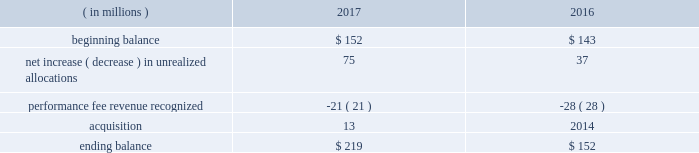When the likelihood of clawback is considered mathematically improbable .
The company records a deferred carried interest liability to the extent it receives cash or capital allocations related to carried interest prior to meeting the revenue recognition criteria .
At december 31 , 2017 and 2016 , the company had $ 219 million and $ 152 million , respectively , of deferred carried interest recorded in other liabilities/other liabilities of consolidated vies on the consolidated statements of financial condition .
A portion of the deferred carried interest liability will be paid to certain employees .
The ultimate timing of the recognition of performance fee revenue , if any , for these products is unknown .
The table presents changes in the deferred carried interest liability ( including the portion related to consolidated vies ) for 2017 and 2016: .
For 2017 , 2016 and 2015 , performance fee revenue ( which included recognized carried interest ) totaled $ 594 million , $ 295 million and $ 621 million , respectively .
Fees earned for technology and risk management revenue are recorded as services are performed and are generally determined using the value of positions on the aladdin platform or on a fixed-rate basis .
For 2017 , 2016 and 2016 , technology and risk management revenue totaled $ 677 million , $ 595 million and $ 528 million , respectively .
Adjustments to revenue arising from initial estimates recorded historically have been immaterial since the majority of blackrock 2019s investment advisory and administration revenue is calculated based on aum and since the company does not record performance fee revenue until performance thresholds have been exceeded and the likelihood of clawback is mathematically improbable .
Accounting developments recent accounting pronouncements not yet adopted .
Revenue from contracts with customers .
In may 2014 , the financial accounting standards board ( 201cfasb 201d ) issued accounting standards update ( 201casu 201d ) 2014-09 , revenue from contracts with customers ( 201casu 2014-09 201d ) .
Asu 2014-09 outlines a single comprehensive model for entities to use in accounting for revenue arising from contracts with customers and supersedes most current revenue recognition guidance , including industry-specific guidance .
The guidance also changes the accounting for certain contract costs and revises the criteria for determining if an entity is acting as a principal or agent in certain arrangements .
The key changes in the standard that impact the company 2019s revenue recognition relate to the presentation of certain revenue contracts and associated contract costs .
The most significant of these changes relates to the presentation of certain distribution costs , which are currently presented net against revenues ( contra-revenue ) and will be presented as an expense on a gross basis .
The company adopted asu 2014-09 effective january 1 , 2018 on a full retrospective basis , which will require 2016 and 2017 to be restated in future filings .
The cumulative effect adjustment to the 2016 opening retained earnings was not material .
The company currently expects the net gross up to revenue to be approximately $ 1 billion with a corresponding gross up to expense for both 2016 and 2017 .
Consequently , the company expects its gaap operating margin to decline upon adoption due to the gross up of revenue .
However , no material impact is expected on the company 2019s as adjusted operating margin .
For accounting pronouncements that the company adopted during the year ended december 31 , 2017 and for additional recent accounting pronouncements not yet adopted , see note 2 , significant accounting policies , in the consolidated financial statements contained in part ii , item 8 of this filing .
Item 7a .
Quantitative and qualitative disclosures about market risk aum market price risk .
Blackrock 2019s investment advisory and administration fees are primarily comprised of fees based on a percentage of the value of aum and , in some cases , performance fees expressed as a percentage of the returns realized on aum .
At december 31 , 2017 , the majority of the company 2019s investment advisory and administration fees were based on average or period end aum of the applicable investment funds or separate accounts .
Movements in equity market prices , interest rates/credit spreads , foreign exchange rates or all three could cause the value of aum to decline , which would result in lower investment advisory and administration fees .
Corporate investments portfolio risks .
As a leading investment management firm , blackrock devotes significant resources across all of its operations to identifying , measuring , monitoring , managing and analyzing market and operating risks , including the management and oversight of its own investment portfolio .
The board of directors of the company has adopted guidelines for the review of investments to be made by the company , requiring , among other things , that investments be reviewed by certain senior officers of the company , and that certain investments may be referred to the audit committee or the board of directors , depending on the circumstances , for approval .
In the normal course of its business , blackrock is exposed to equity market price risk , interest rate/credit spread risk and foreign exchange rate risk associated with its corporate investments .
Blackrock has investments primarily in sponsored investment products that invest in a variety of asset classes , including real assets , private equity and hedge funds .
Investments generally are made for co-investment purposes , to establish a performance track record , to hedge exposure to certain deferred compensation plans or for regulatory purposes .
Currently , the company has a seed capital hedging program in which it enters into swaps to hedge market and interest rate exposure to certain investments .
At december 31 , 2017 , the company had outstanding total return swaps with an aggregate notional value of approximately $ 587 million .
At december 31 , 2017 , there were no outstanding interest rate swaps. .
What percent did the balance increase from the beginning of 2016 to the end of 2017? 
Computations: ((219 / 143) - 1)
Answer: 0.53147. When the likelihood of clawback is considered mathematically improbable .
The company records a deferred carried interest liability to the extent it receives cash or capital allocations related to carried interest prior to meeting the revenue recognition criteria .
At december 31 , 2017 and 2016 , the company had $ 219 million and $ 152 million , respectively , of deferred carried interest recorded in other liabilities/other liabilities of consolidated vies on the consolidated statements of financial condition .
A portion of the deferred carried interest liability will be paid to certain employees .
The ultimate timing of the recognition of performance fee revenue , if any , for these products is unknown .
The table presents changes in the deferred carried interest liability ( including the portion related to consolidated vies ) for 2017 and 2016: .
For 2017 , 2016 and 2015 , performance fee revenue ( which included recognized carried interest ) totaled $ 594 million , $ 295 million and $ 621 million , respectively .
Fees earned for technology and risk management revenue are recorded as services are performed and are generally determined using the value of positions on the aladdin platform or on a fixed-rate basis .
For 2017 , 2016 and 2016 , technology and risk management revenue totaled $ 677 million , $ 595 million and $ 528 million , respectively .
Adjustments to revenue arising from initial estimates recorded historically have been immaterial since the majority of blackrock 2019s investment advisory and administration revenue is calculated based on aum and since the company does not record performance fee revenue until performance thresholds have been exceeded and the likelihood of clawback is mathematically improbable .
Accounting developments recent accounting pronouncements not yet adopted .
Revenue from contracts with customers .
In may 2014 , the financial accounting standards board ( 201cfasb 201d ) issued accounting standards update ( 201casu 201d ) 2014-09 , revenue from contracts with customers ( 201casu 2014-09 201d ) .
Asu 2014-09 outlines a single comprehensive model for entities to use in accounting for revenue arising from contracts with customers and supersedes most current revenue recognition guidance , including industry-specific guidance .
The guidance also changes the accounting for certain contract costs and revises the criteria for determining if an entity is acting as a principal or agent in certain arrangements .
The key changes in the standard that impact the company 2019s revenue recognition relate to the presentation of certain revenue contracts and associated contract costs .
The most significant of these changes relates to the presentation of certain distribution costs , which are currently presented net against revenues ( contra-revenue ) and will be presented as an expense on a gross basis .
The company adopted asu 2014-09 effective january 1 , 2018 on a full retrospective basis , which will require 2016 and 2017 to be restated in future filings .
The cumulative effect adjustment to the 2016 opening retained earnings was not material .
The company currently expects the net gross up to revenue to be approximately $ 1 billion with a corresponding gross up to expense for both 2016 and 2017 .
Consequently , the company expects its gaap operating margin to decline upon adoption due to the gross up of revenue .
However , no material impact is expected on the company 2019s as adjusted operating margin .
For accounting pronouncements that the company adopted during the year ended december 31 , 2017 and for additional recent accounting pronouncements not yet adopted , see note 2 , significant accounting policies , in the consolidated financial statements contained in part ii , item 8 of this filing .
Item 7a .
Quantitative and qualitative disclosures about market risk aum market price risk .
Blackrock 2019s investment advisory and administration fees are primarily comprised of fees based on a percentage of the value of aum and , in some cases , performance fees expressed as a percentage of the returns realized on aum .
At december 31 , 2017 , the majority of the company 2019s investment advisory and administration fees were based on average or period end aum of the applicable investment funds or separate accounts .
Movements in equity market prices , interest rates/credit spreads , foreign exchange rates or all three could cause the value of aum to decline , which would result in lower investment advisory and administration fees .
Corporate investments portfolio risks .
As a leading investment management firm , blackrock devotes significant resources across all of its operations to identifying , measuring , monitoring , managing and analyzing market and operating risks , including the management and oversight of its own investment portfolio .
The board of directors of the company has adopted guidelines for the review of investments to be made by the company , requiring , among other things , that investments be reviewed by certain senior officers of the company , and that certain investments may be referred to the audit committee or the board of directors , depending on the circumstances , for approval .
In the normal course of its business , blackrock is exposed to equity market price risk , interest rate/credit spread risk and foreign exchange rate risk associated with its corporate investments .
Blackrock has investments primarily in sponsored investment products that invest in a variety of asset classes , including real assets , private equity and hedge funds .
Investments generally are made for co-investment purposes , to establish a performance track record , to hedge exposure to certain deferred compensation plans or for regulatory purposes .
Currently , the company has a seed capital hedging program in which it enters into swaps to hedge market and interest rate exposure to certain investments .
At december 31 , 2017 , the company had outstanding total return swaps with an aggregate notional value of approximately $ 587 million .
At december 31 , 2017 , there were no outstanding interest rate swaps. .
What is the growth rate in revenue related technology and risk management from 2015 to 2016? 
Computations: ((595 - 528) / 528)
Answer: 0.12689. 